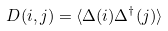Convert formula to latex. <formula><loc_0><loc_0><loc_500><loc_500>D ( i , j ) = \langle \Delta ( i ) \Delta ^ { \dagger } ( j ) \rangle</formula> 